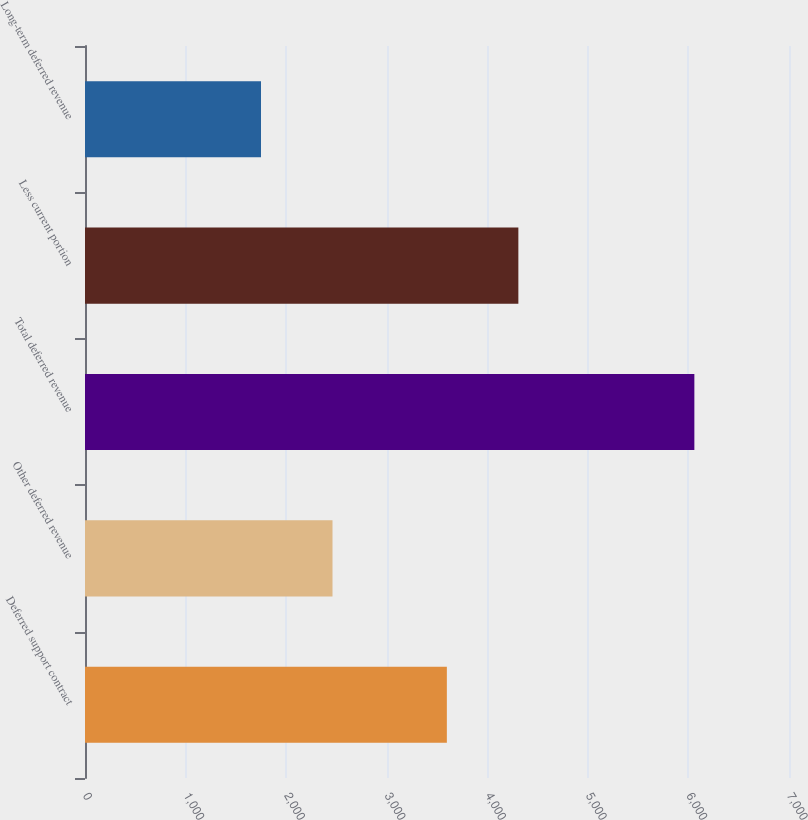<chart> <loc_0><loc_0><loc_500><loc_500><bar_chart><fcel>Deferred support contract<fcel>Other deferred revenue<fcel>Total deferred revenue<fcel>Less current portion<fcel>Long-term deferred revenue<nl><fcel>3598<fcel>2461<fcel>6059<fcel>4309<fcel>1750<nl></chart> 